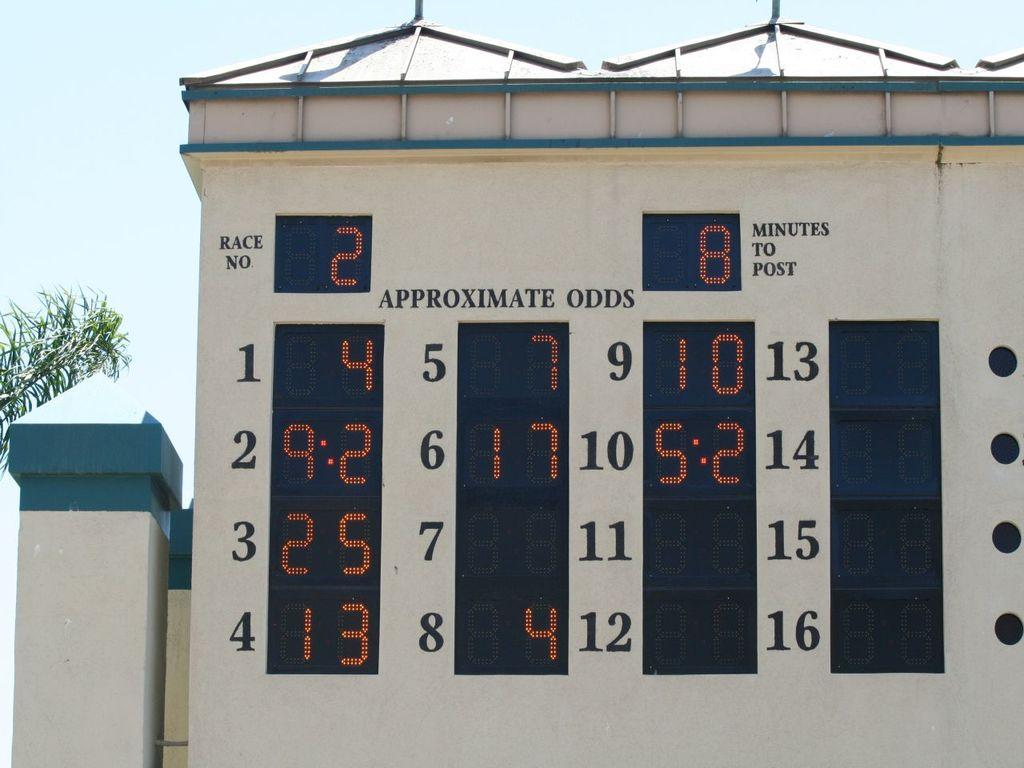<image>
Describe the image concisely. a white sports score board reads Approximate Odds for Race No 2 